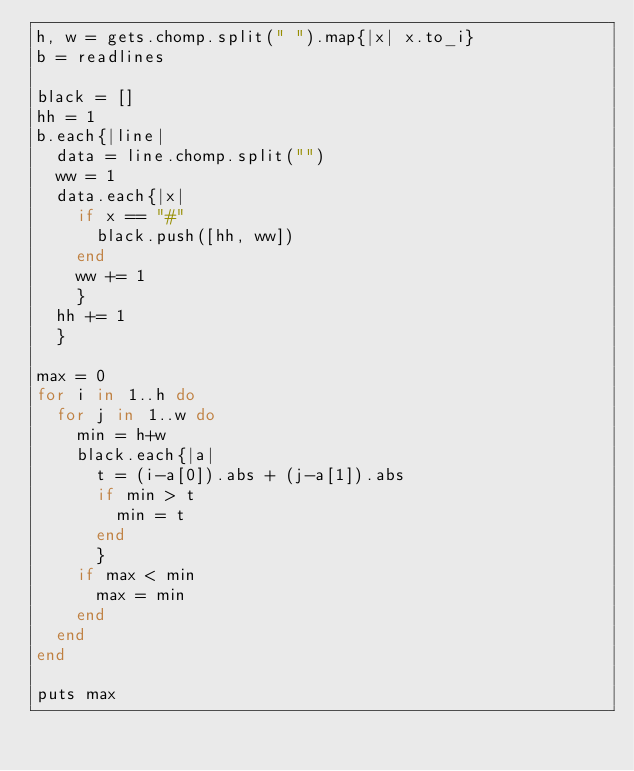Convert code to text. <code><loc_0><loc_0><loc_500><loc_500><_Ruby_>h, w = gets.chomp.split(" ").map{|x| x.to_i}
b = readlines

black = []
hh = 1
b.each{|line|
  data = line.chomp.split("")
  ww = 1
  data.each{|x|
    if x == "#"
      black.push([hh, ww])
    end
    ww += 1
    }
  hh += 1
  }

max = 0
for i in 1..h do
  for j in 1..w do
    min = h+w
    black.each{|a|
      t = (i-a[0]).abs + (j-a[1]).abs
      if min > t
        min = t
      end
      }
    if max < min
      max = min
    end
  end
end

puts max</code> 